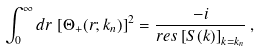<formula> <loc_0><loc_0><loc_500><loc_500>\int _ { 0 } ^ { \infty } d r \, \left [ \Theta _ { + } ( r ; k _ { n } ) \right ] ^ { 2 } = \frac { - i } { r e s \left [ S ( k ) \right ] _ { k = k _ { n } } } \, ,</formula> 